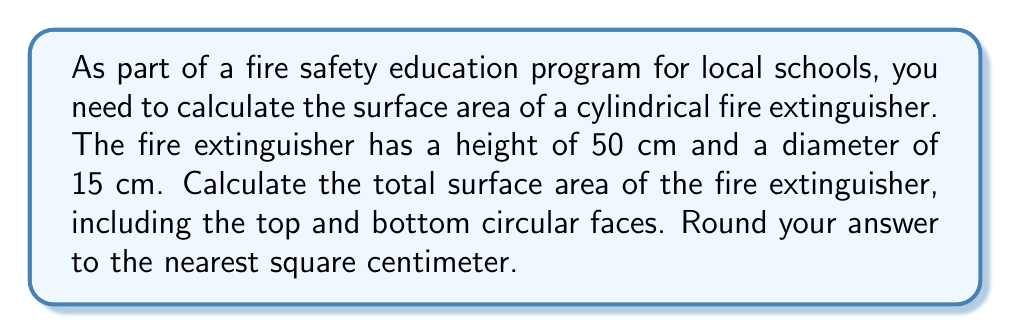Solve this math problem. To calculate the surface area of a cylindrical fire extinguisher, we need to consider three parts:
1. The curved lateral surface
2. The top circular face
3. The bottom circular face

Let's break it down step-by-step:

1. Lateral surface area:
   The lateral surface area of a cylinder is given by the formula: $A_lateral = 2\pi rh$
   where $r$ is the radius and $h$ is the height.
   
   Radius = Diameter ÷ 2 = 15 cm ÷ 2 = 7.5 cm
   Height = 50 cm

   $A_lateral = 2\pi (7.5 \text{ cm})(50 \text{ cm}) = 750\pi \text{ cm}^2$

2. Area of top and bottom circular faces:
   The area of a circle is given by the formula: $A_circle = \pi r^2$
   We need this twice (for top and bottom).

   $A_circles = 2\pi r^2 = 2\pi (7.5 \text{ cm})^2 = 112.5\pi \text{ cm}^2$

3. Total surface area:
   $A_total = A_lateral + A_circles$
   $A_total = 750\pi \text{ cm}^2 + 112.5\pi \text{ cm}^2 = 862.5\pi \text{ cm}^2$

4. Converting to a numerical value:
   $A_total = 862.5\pi \text{ cm}^2 \approx 2709.73 \text{ cm}^2$

5. Rounding to the nearest square centimeter:
   $A_total \approx 2710 \text{ cm}^2$

[asy]
import geometry;

// Draw cylinder
path p = (0,0)--(0,50)--(15,50)--(15,0)--cycle;
draw(p);
draw(arc((7.5,0),7.5,0,180));
draw(arc((7.5,50),7.5,0,180,invisible));
draw(arc((7.5,0),7.5,180,360,dashed));
draw(arc((7.5,50),7.5,180,360));

// Label dimensions
label("50 cm", (16,25), E);
label("15 cm", (7.5,-2), S);

// Draw arrows
draw((16,0)--(16,50), Arrow(TeXHead));
draw((16,50)--(16,0), Arrow(TeXHead));
draw((0,-2)--(15,-2), Arrow(TeXHead));
draw((15,-2)--(0,-2), Arrow(TeXHead));
[/asy]
Answer: The total surface area of the cylindrical fire extinguisher is approximately $2710 \text{ cm}^2$. 